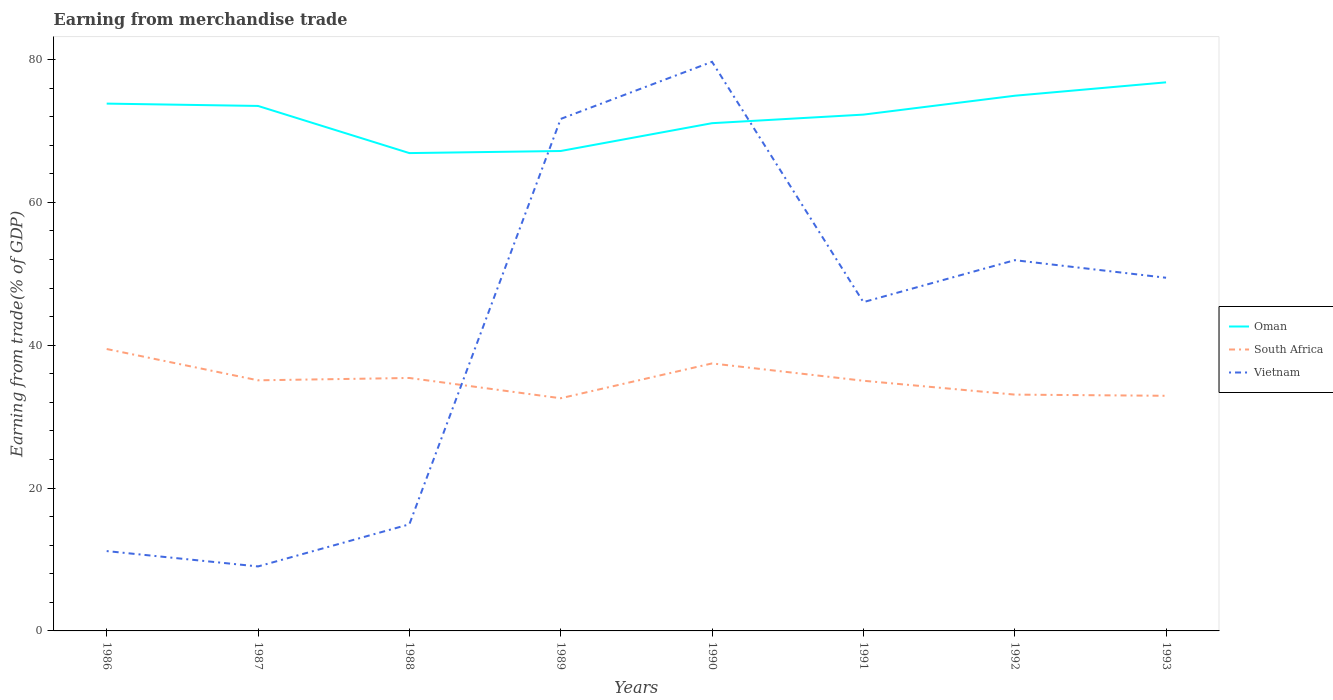How many different coloured lines are there?
Provide a succinct answer. 3. Does the line corresponding to Oman intersect with the line corresponding to South Africa?
Keep it short and to the point. No. Is the number of lines equal to the number of legend labels?
Your answer should be compact. Yes. Across all years, what is the maximum earnings from trade in South Africa?
Give a very brief answer. 32.58. What is the total earnings from trade in Vietnam in the graph?
Make the answer very short. -40.42. What is the difference between the highest and the second highest earnings from trade in Vietnam?
Provide a succinct answer. 70.65. How many lines are there?
Your answer should be compact. 3. What is the difference between two consecutive major ticks on the Y-axis?
Ensure brevity in your answer.  20. How many legend labels are there?
Offer a very short reply. 3. How are the legend labels stacked?
Your answer should be compact. Vertical. What is the title of the graph?
Offer a very short reply. Earning from merchandise trade. Does "Bhutan" appear as one of the legend labels in the graph?
Your response must be concise. No. What is the label or title of the X-axis?
Ensure brevity in your answer.  Years. What is the label or title of the Y-axis?
Your answer should be compact. Earning from trade(% of GDP). What is the Earning from trade(% of GDP) of Oman in 1986?
Give a very brief answer. 73.82. What is the Earning from trade(% of GDP) of South Africa in 1986?
Provide a short and direct response. 39.47. What is the Earning from trade(% of GDP) in Vietnam in 1986?
Your answer should be compact. 11.18. What is the Earning from trade(% of GDP) in Oman in 1987?
Your response must be concise. 73.5. What is the Earning from trade(% of GDP) in South Africa in 1987?
Offer a terse response. 35.08. What is the Earning from trade(% of GDP) of Vietnam in 1987?
Your answer should be compact. 9.03. What is the Earning from trade(% of GDP) in Oman in 1988?
Keep it short and to the point. 66.9. What is the Earning from trade(% of GDP) in South Africa in 1988?
Give a very brief answer. 35.41. What is the Earning from trade(% of GDP) of Vietnam in 1988?
Provide a succinct answer. 14.92. What is the Earning from trade(% of GDP) in Oman in 1989?
Offer a very short reply. 67.19. What is the Earning from trade(% of GDP) of South Africa in 1989?
Offer a terse response. 32.58. What is the Earning from trade(% of GDP) of Vietnam in 1989?
Your response must be concise. 71.68. What is the Earning from trade(% of GDP) of Oman in 1990?
Your answer should be compact. 71.08. What is the Earning from trade(% of GDP) in South Africa in 1990?
Keep it short and to the point. 37.45. What is the Earning from trade(% of GDP) of Vietnam in 1990?
Your answer should be compact. 79.68. What is the Earning from trade(% of GDP) of Oman in 1991?
Provide a succinct answer. 72.28. What is the Earning from trade(% of GDP) of South Africa in 1991?
Your response must be concise. 35.02. What is the Earning from trade(% of GDP) of Vietnam in 1991?
Your answer should be compact. 46.03. What is the Earning from trade(% of GDP) in Oman in 1992?
Give a very brief answer. 74.93. What is the Earning from trade(% of GDP) of South Africa in 1992?
Provide a short and direct response. 33.08. What is the Earning from trade(% of GDP) of Vietnam in 1992?
Provide a succinct answer. 51.9. What is the Earning from trade(% of GDP) in Oman in 1993?
Your answer should be compact. 76.8. What is the Earning from trade(% of GDP) of South Africa in 1993?
Ensure brevity in your answer.  32.92. What is the Earning from trade(% of GDP) of Vietnam in 1993?
Keep it short and to the point. 49.44. Across all years, what is the maximum Earning from trade(% of GDP) of Oman?
Ensure brevity in your answer.  76.8. Across all years, what is the maximum Earning from trade(% of GDP) of South Africa?
Ensure brevity in your answer.  39.47. Across all years, what is the maximum Earning from trade(% of GDP) of Vietnam?
Offer a very short reply. 79.68. Across all years, what is the minimum Earning from trade(% of GDP) of Oman?
Offer a terse response. 66.9. Across all years, what is the minimum Earning from trade(% of GDP) in South Africa?
Ensure brevity in your answer.  32.58. Across all years, what is the minimum Earning from trade(% of GDP) in Vietnam?
Offer a terse response. 9.03. What is the total Earning from trade(% of GDP) in Oman in the graph?
Make the answer very short. 576.5. What is the total Earning from trade(% of GDP) in South Africa in the graph?
Keep it short and to the point. 281.01. What is the total Earning from trade(% of GDP) in Vietnam in the graph?
Ensure brevity in your answer.  333.86. What is the difference between the Earning from trade(% of GDP) of Oman in 1986 and that in 1987?
Provide a short and direct response. 0.33. What is the difference between the Earning from trade(% of GDP) of South Africa in 1986 and that in 1987?
Keep it short and to the point. 4.38. What is the difference between the Earning from trade(% of GDP) of Vietnam in 1986 and that in 1987?
Offer a terse response. 2.15. What is the difference between the Earning from trade(% of GDP) in Oman in 1986 and that in 1988?
Make the answer very short. 6.93. What is the difference between the Earning from trade(% of GDP) of South Africa in 1986 and that in 1988?
Keep it short and to the point. 4.05. What is the difference between the Earning from trade(% of GDP) in Vietnam in 1986 and that in 1988?
Give a very brief answer. -3.74. What is the difference between the Earning from trade(% of GDP) in Oman in 1986 and that in 1989?
Offer a very short reply. 6.64. What is the difference between the Earning from trade(% of GDP) of South Africa in 1986 and that in 1989?
Provide a succinct answer. 6.89. What is the difference between the Earning from trade(% of GDP) of Vietnam in 1986 and that in 1989?
Your answer should be very brief. -60.5. What is the difference between the Earning from trade(% of GDP) of Oman in 1986 and that in 1990?
Your answer should be compact. 2.74. What is the difference between the Earning from trade(% of GDP) of South Africa in 1986 and that in 1990?
Ensure brevity in your answer.  2.02. What is the difference between the Earning from trade(% of GDP) of Vietnam in 1986 and that in 1990?
Your answer should be compact. -68.5. What is the difference between the Earning from trade(% of GDP) in Oman in 1986 and that in 1991?
Offer a terse response. 1.54. What is the difference between the Earning from trade(% of GDP) of South Africa in 1986 and that in 1991?
Your answer should be very brief. 4.44. What is the difference between the Earning from trade(% of GDP) in Vietnam in 1986 and that in 1991?
Ensure brevity in your answer.  -34.85. What is the difference between the Earning from trade(% of GDP) of Oman in 1986 and that in 1992?
Provide a succinct answer. -1.1. What is the difference between the Earning from trade(% of GDP) of South Africa in 1986 and that in 1992?
Offer a terse response. 6.38. What is the difference between the Earning from trade(% of GDP) of Vietnam in 1986 and that in 1992?
Provide a short and direct response. -40.73. What is the difference between the Earning from trade(% of GDP) in Oman in 1986 and that in 1993?
Offer a terse response. -2.98. What is the difference between the Earning from trade(% of GDP) in South Africa in 1986 and that in 1993?
Your answer should be very brief. 6.55. What is the difference between the Earning from trade(% of GDP) in Vietnam in 1986 and that in 1993?
Offer a very short reply. -38.27. What is the difference between the Earning from trade(% of GDP) in Oman in 1987 and that in 1988?
Your response must be concise. 6.6. What is the difference between the Earning from trade(% of GDP) of South Africa in 1987 and that in 1988?
Your response must be concise. -0.33. What is the difference between the Earning from trade(% of GDP) of Vietnam in 1987 and that in 1988?
Offer a terse response. -5.9. What is the difference between the Earning from trade(% of GDP) in Oman in 1987 and that in 1989?
Offer a terse response. 6.31. What is the difference between the Earning from trade(% of GDP) in South Africa in 1987 and that in 1989?
Keep it short and to the point. 2.51. What is the difference between the Earning from trade(% of GDP) of Vietnam in 1987 and that in 1989?
Offer a terse response. -62.65. What is the difference between the Earning from trade(% of GDP) in Oman in 1987 and that in 1990?
Ensure brevity in your answer.  2.41. What is the difference between the Earning from trade(% of GDP) of South Africa in 1987 and that in 1990?
Ensure brevity in your answer.  -2.36. What is the difference between the Earning from trade(% of GDP) in Vietnam in 1987 and that in 1990?
Make the answer very short. -70.65. What is the difference between the Earning from trade(% of GDP) in Oman in 1987 and that in 1991?
Your answer should be very brief. 1.21. What is the difference between the Earning from trade(% of GDP) in South Africa in 1987 and that in 1991?
Your answer should be very brief. 0.06. What is the difference between the Earning from trade(% of GDP) of Vietnam in 1987 and that in 1991?
Your answer should be compact. -37.01. What is the difference between the Earning from trade(% of GDP) of Oman in 1987 and that in 1992?
Keep it short and to the point. -1.43. What is the difference between the Earning from trade(% of GDP) of South Africa in 1987 and that in 1992?
Give a very brief answer. 2. What is the difference between the Earning from trade(% of GDP) in Vietnam in 1987 and that in 1992?
Your response must be concise. -42.88. What is the difference between the Earning from trade(% of GDP) of Oman in 1987 and that in 1993?
Provide a short and direct response. -3.31. What is the difference between the Earning from trade(% of GDP) in South Africa in 1987 and that in 1993?
Provide a short and direct response. 2.17. What is the difference between the Earning from trade(% of GDP) of Vietnam in 1987 and that in 1993?
Your answer should be compact. -40.42. What is the difference between the Earning from trade(% of GDP) in Oman in 1988 and that in 1989?
Your answer should be very brief. -0.29. What is the difference between the Earning from trade(% of GDP) in South Africa in 1988 and that in 1989?
Provide a succinct answer. 2.84. What is the difference between the Earning from trade(% of GDP) in Vietnam in 1988 and that in 1989?
Your response must be concise. -56.76. What is the difference between the Earning from trade(% of GDP) in Oman in 1988 and that in 1990?
Keep it short and to the point. -4.19. What is the difference between the Earning from trade(% of GDP) of South Africa in 1988 and that in 1990?
Your answer should be compact. -2.04. What is the difference between the Earning from trade(% of GDP) in Vietnam in 1988 and that in 1990?
Your answer should be very brief. -64.75. What is the difference between the Earning from trade(% of GDP) of Oman in 1988 and that in 1991?
Your answer should be compact. -5.39. What is the difference between the Earning from trade(% of GDP) in South Africa in 1988 and that in 1991?
Your response must be concise. 0.39. What is the difference between the Earning from trade(% of GDP) of Vietnam in 1988 and that in 1991?
Your response must be concise. -31.11. What is the difference between the Earning from trade(% of GDP) in Oman in 1988 and that in 1992?
Give a very brief answer. -8.03. What is the difference between the Earning from trade(% of GDP) in South Africa in 1988 and that in 1992?
Give a very brief answer. 2.33. What is the difference between the Earning from trade(% of GDP) in Vietnam in 1988 and that in 1992?
Offer a terse response. -36.98. What is the difference between the Earning from trade(% of GDP) in Oman in 1988 and that in 1993?
Keep it short and to the point. -9.91. What is the difference between the Earning from trade(% of GDP) in South Africa in 1988 and that in 1993?
Keep it short and to the point. 2.49. What is the difference between the Earning from trade(% of GDP) in Vietnam in 1988 and that in 1993?
Give a very brief answer. -34.52. What is the difference between the Earning from trade(% of GDP) in Oman in 1989 and that in 1990?
Offer a very short reply. -3.89. What is the difference between the Earning from trade(% of GDP) in South Africa in 1989 and that in 1990?
Offer a very short reply. -4.87. What is the difference between the Earning from trade(% of GDP) of Vietnam in 1989 and that in 1990?
Offer a very short reply. -8. What is the difference between the Earning from trade(% of GDP) in Oman in 1989 and that in 1991?
Provide a succinct answer. -5.1. What is the difference between the Earning from trade(% of GDP) in South Africa in 1989 and that in 1991?
Your answer should be compact. -2.45. What is the difference between the Earning from trade(% of GDP) in Vietnam in 1989 and that in 1991?
Your answer should be compact. 25.65. What is the difference between the Earning from trade(% of GDP) in Oman in 1989 and that in 1992?
Ensure brevity in your answer.  -7.74. What is the difference between the Earning from trade(% of GDP) of South Africa in 1989 and that in 1992?
Keep it short and to the point. -0.51. What is the difference between the Earning from trade(% of GDP) of Vietnam in 1989 and that in 1992?
Provide a short and direct response. 19.77. What is the difference between the Earning from trade(% of GDP) in Oman in 1989 and that in 1993?
Give a very brief answer. -9.61. What is the difference between the Earning from trade(% of GDP) in South Africa in 1989 and that in 1993?
Keep it short and to the point. -0.34. What is the difference between the Earning from trade(% of GDP) of Vietnam in 1989 and that in 1993?
Give a very brief answer. 22.24. What is the difference between the Earning from trade(% of GDP) in Oman in 1990 and that in 1991?
Provide a succinct answer. -1.2. What is the difference between the Earning from trade(% of GDP) in South Africa in 1990 and that in 1991?
Offer a terse response. 2.42. What is the difference between the Earning from trade(% of GDP) of Vietnam in 1990 and that in 1991?
Your answer should be compact. 33.64. What is the difference between the Earning from trade(% of GDP) in Oman in 1990 and that in 1992?
Ensure brevity in your answer.  -3.84. What is the difference between the Earning from trade(% of GDP) in South Africa in 1990 and that in 1992?
Ensure brevity in your answer.  4.37. What is the difference between the Earning from trade(% of GDP) of Vietnam in 1990 and that in 1992?
Provide a short and direct response. 27.77. What is the difference between the Earning from trade(% of GDP) of Oman in 1990 and that in 1993?
Your response must be concise. -5.72. What is the difference between the Earning from trade(% of GDP) in South Africa in 1990 and that in 1993?
Offer a terse response. 4.53. What is the difference between the Earning from trade(% of GDP) in Vietnam in 1990 and that in 1993?
Ensure brevity in your answer.  30.23. What is the difference between the Earning from trade(% of GDP) in Oman in 1991 and that in 1992?
Your answer should be compact. -2.64. What is the difference between the Earning from trade(% of GDP) of South Africa in 1991 and that in 1992?
Offer a very short reply. 1.94. What is the difference between the Earning from trade(% of GDP) of Vietnam in 1991 and that in 1992?
Give a very brief answer. -5.87. What is the difference between the Earning from trade(% of GDP) of Oman in 1991 and that in 1993?
Your answer should be compact. -4.52. What is the difference between the Earning from trade(% of GDP) of South Africa in 1991 and that in 1993?
Keep it short and to the point. 2.11. What is the difference between the Earning from trade(% of GDP) in Vietnam in 1991 and that in 1993?
Provide a short and direct response. -3.41. What is the difference between the Earning from trade(% of GDP) of Oman in 1992 and that in 1993?
Offer a terse response. -1.88. What is the difference between the Earning from trade(% of GDP) in South Africa in 1992 and that in 1993?
Keep it short and to the point. 0.16. What is the difference between the Earning from trade(% of GDP) of Vietnam in 1992 and that in 1993?
Provide a succinct answer. 2.46. What is the difference between the Earning from trade(% of GDP) in Oman in 1986 and the Earning from trade(% of GDP) in South Africa in 1987?
Provide a short and direct response. 38.74. What is the difference between the Earning from trade(% of GDP) of Oman in 1986 and the Earning from trade(% of GDP) of Vietnam in 1987?
Ensure brevity in your answer.  64.8. What is the difference between the Earning from trade(% of GDP) of South Africa in 1986 and the Earning from trade(% of GDP) of Vietnam in 1987?
Keep it short and to the point. 30.44. What is the difference between the Earning from trade(% of GDP) of Oman in 1986 and the Earning from trade(% of GDP) of South Africa in 1988?
Keep it short and to the point. 38.41. What is the difference between the Earning from trade(% of GDP) in Oman in 1986 and the Earning from trade(% of GDP) in Vietnam in 1988?
Give a very brief answer. 58.9. What is the difference between the Earning from trade(% of GDP) of South Africa in 1986 and the Earning from trade(% of GDP) of Vietnam in 1988?
Ensure brevity in your answer.  24.54. What is the difference between the Earning from trade(% of GDP) of Oman in 1986 and the Earning from trade(% of GDP) of South Africa in 1989?
Offer a terse response. 41.25. What is the difference between the Earning from trade(% of GDP) in Oman in 1986 and the Earning from trade(% of GDP) in Vietnam in 1989?
Offer a terse response. 2.14. What is the difference between the Earning from trade(% of GDP) of South Africa in 1986 and the Earning from trade(% of GDP) of Vietnam in 1989?
Your answer should be compact. -32.21. What is the difference between the Earning from trade(% of GDP) in Oman in 1986 and the Earning from trade(% of GDP) in South Africa in 1990?
Make the answer very short. 36.38. What is the difference between the Earning from trade(% of GDP) of Oman in 1986 and the Earning from trade(% of GDP) of Vietnam in 1990?
Your response must be concise. -5.85. What is the difference between the Earning from trade(% of GDP) in South Africa in 1986 and the Earning from trade(% of GDP) in Vietnam in 1990?
Ensure brevity in your answer.  -40.21. What is the difference between the Earning from trade(% of GDP) in Oman in 1986 and the Earning from trade(% of GDP) in South Africa in 1991?
Your answer should be compact. 38.8. What is the difference between the Earning from trade(% of GDP) in Oman in 1986 and the Earning from trade(% of GDP) in Vietnam in 1991?
Make the answer very short. 27.79. What is the difference between the Earning from trade(% of GDP) in South Africa in 1986 and the Earning from trade(% of GDP) in Vietnam in 1991?
Your answer should be very brief. -6.56. What is the difference between the Earning from trade(% of GDP) in Oman in 1986 and the Earning from trade(% of GDP) in South Africa in 1992?
Provide a succinct answer. 40.74. What is the difference between the Earning from trade(% of GDP) of Oman in 1986 and the Earning from trade(% of GDP) of Vietnam in 1992?
Your answer should be compact. 21.92. What is the difference between the Earning from trade(% of GDP) in South Africa in 1986 and the Earning from trade(% of GDP) in Vietnam in 1992?
Ensure brevity in your answer.  -12.44. What is the difference between the Earning from trade(% of GDP) of Oman in 1986 and the Earning from trade(% of GDP) of South Africa in 1993?
Your answer should be compact. 40.91. What is the difference between the Earning from trade(% of GDP) in Oman in 1986 and the Earning from trade(% of GDP) in Vietnam in 1993?
Your answer should be very brief. 24.38. What is the difference between the Earning from trade(% of GDP) in South Africa in 1986 and the Earning from trade(% of GDP) in Vietnam in 1993?
Give a very brief answer. -9.98. What is the difference between the Earning from trade(% of GDP) of Oman in 1987 and the Earning from trade(% of GDP) of South Africa in 1988?
Offer a very short reply. 38.08. What is the difference between the Earning from trade(% of GDP) in Oman in 1987 and the Earning from trade(% of GDP) in Vietnam in 1988?
Give a very brief answer. 58.57. What is the difference between the Earning from trade(% of GDP) in South Africa in 1987 and the Earning from trade(% of GDP) in Vietnam in 1988?
Ensure brevity in your answer.  20.16. What is the difference between the Earning from trade(% of GDP) in Oman in 1987 and the Earning from trade(% of GDP) in South Africa in 1989?
Provide a short and direct response. 40.92. What is the difference between the Earning from trade(% of GDP) of Oman in 1987 and the Earning from trade(% of GDP) of Vietnam in 1989?
Offer a very short reply. 1.82. What is the difference between the Earning from trade(% of GDP) of South Africa in 1987 and the Earning from trade(% of GDP) of Vietnam in 1989?
Give a very brief answer. -36.59. What is the difference between the Earning from trade(% of GDP) in Oman in 1987 and the Earning from trade(% of GDP) in South Africa in 1990?
Keep it short and to the point. 36.05. What is the difference between the Earning from trade(% of GDP) of Oman in 1987 and the Earning from trade(% of GDP) of Vietnam in 1990?
Offer a very short reply. -6.18. What is the difference between the Earning from trade(% of GDP) of South Africa in 1987 and the Earning from trade(% of GDP) of Vietnam in 1990?
Give a very brief answer. -44.59. What is the difference between the Earning from trade(% of GDP) in Oman in 1987 and the Earning from trade(% of GDP) in South Africa in 1991?
Your response must be concise. 38.47. What is the difference between the Earning from trade(% of GDP) of Oman in 1987 and the Earning from trade(% of GDP) of Vietnam in 1991?
Give a very brief answer. 27.47. What is the difference between the Earning from trade(% of GDP) in South Africa in 1987 and the Earning from trade(% of GDP) in Vietnam in 1991?
Give a very brief answer. -10.95. What is the difference between the Earning from trade(% of GDP) in Oman in 1987 and the Earning from trade(% of GDP) in South Africa in 1992?
Give a very brief answer. 40.41. What is the difference between the Earning from trade(% of GDP) in Oman in 1987 and the Earning from trade(% of GDP) in Vietnam in 1992?
Your response must be concise. 21.59. What is the difference between the Earning from trade(% of GDP) of South Africa in 1987 and the Earning from trade(% of GDP) of Vietnam in 1992?
Provide a short and direct response. -16.82. What is the difference between the Earning from trade(% of GDP) of Oman in 1987 and the Earning from trade(% of GDP) of South Africa in 1993?
Your response must be concise. 40.58. What is the difference between the Earning from trade(% of GDP) in Oman in 1987 and the Earning from trade(% of GDP) in Vietnam in 1993?
Make the answer very short. 24.05. What is the difference between the Earning from trade(% of GDP) in South Africa in 1987 and the Earning from trade(% of GDP) in Vietnam in 1993?
Make the answer very short. -14.36. What is the difference between the Earning from trade(% of GDP) in Oman in 1988 and the Earning from trade(% of GDP) in South Africa in 1989?
Provide a short and direct response. 34.32. What is the difference between the Earning from trade(% of GDP) of Oman in 1988 and the Earning from trade(% of GDP) of Vietnam in 1989?
Provide a succinct answer. -4.78. What is the difference between the Earning from trade(% of GDP) of South Africa in 1988 and the Earning from trade(% of GDP) of Vietnam in 1989?
Provide a succinct answer. -36.27. What is the difference between the Earning from trade(% of GDP) of Oman in 1988 and the Earning from trade(% of GDP) of South Africa in 1990?
Offer a terse response. 29.45. What is the difference between the Earning from trade(% of GDP) in Oman in 1988 and the Earning from trade(% of GDP) in Vietnam in 1990?
Your answer should be very brief. -12.78. What is the difference between the Earning from trade(% of GDP) of South Africa in 1988 and the Earning from trade(% of GDP) of Vietnam in 1990?
Your answer should be very brief. -44.26. What is the difference between the Earning from trade(% of GDP) in Oman in 1988 and the Earning from trade(% of GDP) in South Africa in 1991?
Your response must be concise. 31.87. What is the difference between the Earning from trade(% of GDP) in Oman in 1988 and the Earning from trade(% of GDP) in Vietnam in 1991?
Make the answer very short. 20.86. What is the difference between the Earning from trade(% of GDP) of South Africa in 1988 and the Earning from trade(% of GDP) of Vietnam in 1991?
Your answer should be very brief. -10.62. What is the difference between the Earning from trade(% of GDP) in Oman in 1988 and the Earning from trade(% of GDP) in South Africa in 1992?
Keep it short and to the point. 33.81. What is the difference between the Earning from trade(% of GDP) in Oman in 1988 and the Earning from trade(% of GDP) in Vietnam in 1992?
Your answer should be compact. 14.99. What is the difference between the Earning from trade(% of GDP) in South Africa in 1988 and the Earning from trade(% of GDP) in Vietnam in 1992?
Offer a very short reply. -16.49. What is the difference between the Earning from trade(% of GDP) in Oman in 1988 and the Earning from trade(% of GDP) in South Africa in 1993?
Your answer should be compact. 33.98. What is the difference between the Earning from trade(% of GDP) in Oman in 1988 and the Earning from trade(% of GDP) in Vietnam in 1993?
Provide a short and direct response. 17.45. What is the difference between the Earning from trade(% of GDP) in South Africa in 1988 and the Earning from trade(% of GDP) in Vietnam in 1993?
Offer a terse response. -14.03. What is the difference between the Earning from trade(% of GDP) of Oman in 1989 and the Earning from trade(% of GDP) of South Africa in 1990?
Your answer should be compact. 29.74. What is the difference between the Earning from trade(% of GDP) of Oman in 1989 and the Earning from trade(% of GDP) of Vietnam in 1990?
Make the answer very short. -12.49. What is the difference between the Earning from trade(% of GDP) of South Africa in 1989 and the Earning from trade(% of GDP) of Vietnam in 1990?
Provide a short and direct response. -47.1. What is the difference between the Earning from trade(% of GDP) of Oman in 1989 and the Earning from trade(% of GDP) of South Africa in 1991?
Provide a short and direct response. 32.16. What is the difference between the Earning from trade(% of GDP) in Oman in 1989 and the Earning from trade(% of GDP) in Vietnam in 1991?
Provide a succinct answer. 21.16. What is the difference between the Earning from trade(% of GDP) in South Africa in 1989 and the Earning from trade(% of GDP) in Vietnam in 1991?
Your response must be concise. -13.46. What is the difference between the Earning from trade(% of GDP) in Oman in 1989 and the Earning from trade(% of GDP) in South Africa in 1992?
Provide a succinct answer. 34.11. What is the difference between the Earning from trade(% of GDP) in Oman in 1989 and the Earning from trade(% of GDP) in Vietnam in 1992?
Offer a terse response. 15.28. What is the difference between the Earning from trade(% of GDP) of South Africa in 1989 and the Earning from trade(% of GDP) of Vietnam in 1992?
Your answer should be very brief. -19.33. What is the difference between the Earning from trade(% of GDP) in Oman in 1989 and the Earning from trade(% of GDP) in South Africa in 1993?
Offer a terse response. 34.27. What is the difference between the Earning from trade(% of GDP) of Oman in 1989 and the Earning from trade(% of GDP) of Vietnam in 1993?
Your response must be concise. 17.74. What is the difference between the Earning from trade(% of GDP) of South Africa in 1989 and the Earning from trade(% of GDP) of Vietnam in 1993?
Ensure brevity in your answer.  -16.87. What is the difference between the Earning from trade(% of GDP) in Oman in 1990 and the Earning from trade(% of GDP) in South Africa in 1991?
Give a very brief answer. 36.06. What is the difference between the Earning from trade(% of GDP) of Oman in 1990 and the Earning from trade(% of GDP) of Vietnam in 1991?
Offer a very short reply. 25.05. What is the difference between the Earning from trade(% of GDP) in South Africa in 1990 and the Earning from trade(% of GDP) in Vietnam in 1991?
Offer a terse response. -8.58. What is the difference between the Earning from trade(% of GDP) in Oman in 1990 and the Earning from trade(% of GDP) in South Africa in 1992?
Give a very brief answer. 38. What is the difference between the Earning from trade(% of GDP) in Oman in 1990 and the Earning from trade(% of GDP) in Vietnam in 1992?
Your answer should be compact. 19.18. What is the difference between the Earning from trade(% of GDP) of South Africa in 1990 and the Earning from trade(% of GDP) of Vietnam in 1992?
Keep it short and to the point. -14.46. What is the difference between the Earning from trade(% of GDP) in Oman in 1990 and the Earning from trade(% of GDP) in South Africa in 1993?
Provide a succinct answer. 38.16. What is the difference between the Earning from trade(% of GDP) in Oman in 1990 and the Earning from trade(% of GDP) in Vietnam in 1993?
Provide a short and direct response. 21.64. What is the difference between the Earning from trade(% of GDP) of South Africa in 1990 and the Earning from trade(% of GDP) of Vietnam in 1993?
Offer a very short reply. -12. What is the difference between the Earning from trade(% of GDP) in Oman in 1991 and the Earning from trade(% of GDP) in South Africa in 1992?
Provide a short and direct response. 39.2. What is the difference between the Earning from trade(% of GDP) in Oman in 1991 and the Earning from trade(% of GDP) in Vietnam in 1992?
Your answer should be very brief. 20.38. What is the difference between the Earning from trade(% of GDP) in South Africa in 1991 and the Earning from trade(% of GDP) in Vietnam in 1992?
Provide a succinct answer. -16.88. What is the difference between the Earning from trade(% of GDP) of Oman in 1991 and the Earning from trade(% of GDP) of South Africa in 1993?
Your answer should be very brief. 39.36. What is the difference between the Earning from trade(% of GDP) in Oman in 1991 and the Earning from trade(% of GDP) in Vietnam in 1993?
Provide a short and direct response. 22.84. What is the difference between the Earning from trade(% of GDP) in South Africa in 1991 and the Earning from trade(% of GDP) in Vietnam in 1993?
Ensure brevity in your answer.  -14.42. What is the difference between the Earning from trade(% of GDP) in Oman in 1992 and the Earning from trade(% of GDP) in South Africa in 1993?
Offer a terse response. 42.01. What is the difference between the Earning from trade(% of GDP) in Oman in 1992 and the Earning from trade(% of GDP) in Vietnam in 1993?
Offer a very short reply. 25.48. What is the difference between the Earning from trade(% of GDP) in South Africa in 1992 and the Earning from trade(% of GDP) in Vietnam in 1993?
Make the answer very short. -16.36. What is the average Earning from trade(% of GDP) of Oman per year?
Give a very brief answer. 72.06. What is the average Earning from trade(% of GDP) in South Africa per year?
Offer a terse response. 35.13. What is the average Earning from trade(% of GDP) in Vietnam per year?
Give a very brief answer. 41.73. In the year 1986, what is the difference between the Earning from trade(% of GDP) in Oman and Earning from trade(% of GDP) in South Africa?
Make the answer very short. 34.36. In the year 1986, what is the difference between the Earning from trade(% of GDP) of Oman and Earning from trade(% of GDP) of Vietnam?
Provide a short and direct response. 62.65. In the year 1986, what is the difference between the Earning from trade(% of GDP) in South Africa and Earning from trade(% of GDP) in Vietnam?
Your answer should be very brief. 28.29. In the year 1987, what is the difference between the Earning from trade(% of GDP) in Oman and Earning from trade(% of GDP) in South Africa?
Make the answer very short. 38.41. In the year 1987, what is the difference between the Earning from trade(% of GDP) of Oman and Earning from trade(% of GDP) of Vietnam?
Keep it short and to the point. 64.47. In the year 1987, what is the difference between the Earning from trade(% of GDP) of South Africa and Earning from trade(% of GDP) of Vietnam?
Offer a terse response. 26.06. In the year 1988, what is the difference between the Earning from trade(% of GDP) in Oman and Earning from trade(% of GDP) in South Africa?
Provide a succinct answer. 31.48. In the year 1988, what is the difference between the Earning from trade(% of GDP) in Oman and Earning from trade(% of GDP) in Vietnam?
Provide a short and direct response. 51.97. In the year 1988, what is the difference between the Earning from trade(% of GDP) in South Africa and Earning from trade(% of GDP) in Vietnam?
Your response must be concise. 20.49. In the year 1989, what is the difference between the Earning from trade(% of GDP) in Oman and Earning from trade(% of GDP) in South Africa?
Your answer should be compact. 34.61. In the year 1989, what is the difference between the Earning from trade(% of GDP) of Oman and Earning from trade(% of GDP) of Vietnam?
Your answer should be compact. -4.49. In the year 1989, what is the difference between the Earning from trade(% of GDP) of South Africa and Earning from trade(% of GDP) of Vietnam?
Provide a short and direct response. -39.1. In the year 1990, what is the difference between the Earning from trade(% of GDP) in Oman and Earning from trade(% of GDP) in South Africa?
Ensure brevity in your answer.  33.63. In the year 1990, what is the difference between the Earning from trade(% of GDP) of Oman and Earning from trade(% of GDP) of Vietnam?
Your response must be concise. -8.59. In the year 1990, what is the difference between the Earning from trade(% of GDP) of South Africa and Earning from trade(% of GDP) of Vietnam?
Your response must be concise. -42.23. In the year 1991, what is the difference between the Earning from trade(% of GDP) of Oman and Earning from trade(% of GDP) of South Africa?
Your response must be concise. 37.26. In the year 1991, what is the difference between the Earning from trade(% of GDP) of Oman and Earning from trade(% of GDP) of Vietnam?
Your answer should be very brief. 26.25. In the year 1991, what is the difference between the Earning from trade(% of GDP) in South Africa and Earning from trade(% of GDP) in Vietnam?
Offer a very short reply. -11.01. In the year 1992, what is the difference between the Earning from trade(% of GDP) in Oman and Earning from trade(% of GDP) in South Africa?
Offer a very short reply. 41.84. In the year 1992, what is the difference between the Earning from trade(% of GDP) of Oman and Earning from trade(% of GDP) of Vietnam?
Offer a very short reply. 23.02. In the year 1992, what is the difference between the Earning from trade(% of GDP) of South Africa and Earning from trade(% of GDP) of Vietnam?
Your response must be concise. -18.82. In the year 1993, what is the difference between the Earning from trade(% of GDP) of Oman and Earning from trade(% of GDP) of South Africa?
Offer a terse response. 43.88. In the year 1993, what is the difference between the Earning from trade(% of GDP) in Oman and Earning from trade(% of GDP) in Vietnam?
Ensure brevity in your answer.  27.36. In the year 1993, what is the difference between the Earning from trade(% of GDP) in South Africa and Earning from trade(% of GDP) in Vietnam?
Offer a terse response. -16.53. What is the ratio of the Earning from trade(% of GDP) of South Africa in 1986 to that in 1987?
Make the answer very short. 1.12. What is the ratio of the Earning from trade(% of GDP) of Vietnam in 1986 to that in 1987?
Offer a terse response. 1.24. What is the ratio of the Earning from trade(% of GDP) of Oman in 1986 to that in 1988?
Your answer should be compact. 1.1. What is the ratio of the Earning from trade(% of GDP) of South Africa in 1986 to that in 1988?
Give a very brief answer. 1.11. What is the ratio of the Earning from trade(% of GDP) of Vietnam in 1986 to that in 1988?
Make the answer very short. 0.75. What is the ratio of the Earning from trade(% of GDP) in Oman in 1986 to that in 1989?
Make the answer very short. 1.1. What is the ratio of the Earning from trade(% of GDP) in South Africa in 1986 to that in 1989?
Make the answer very short. 1.21. What is the ratio of the Earning from trade(% of GDP) of Vietnam in 1986 to that in 1989?
Offer a terse response. 0.16. What is the ratio of the Earning from trade(% of GDP) in Oman in 1986 to that in 1990?
Offer a terse response. 1.04. What is the ratio of the Earning from trade(% of GDP) of South Africa in 1986 to that in 1990?
Offer a terse response. 1.05. What is the ratio of the Earning from trade(% of GDP) of Vietnam in 1986 to that in 1990?
Your response must be concise. 0.14. What is the ratio of the Earning from trade(% of GDP) of Oman in 1986 to that in 1991?
Your answer should be compact. 1.02. What is the ratio of the Earning from trade(% of GDP) of South Africa in 1986 to that in 1991?
Provide a short and direct response. 1.13. What is the ratio of the Earning from trade(% of GDP) of Vietnam in 1986 to that in 1991?
Make the answer very short. 0.24. What is the ratio of the Earning from trade(% of GDP) in Oman in 1986 to that in 1992?
Make the answer very short. 0.99. What is the ratio of the Earning from trade(% of GDP) in South Africa in 1986 to that in 1992?
Offer a very short reply. 1.19. What is the ratio of the Earning from trade(% of GDP) in Vietnam in 1986 to that in 1992?
Offer a terse response. 0.22. What is the ratio of the Earning from trade(% of GDP) in Oman in 1986 to that in 1993?
Provide a short and direct response. 0.96. What is the ratio of the Earning from trade(% of GDP) in South Africa in 1986 to that in 1993?
Keep it short and to the point. 1.2. What is the ratio of the Earning from trade(% of GDP) in Vietnam in 1986 to that in 1993?
Your answer should be very brief. 0.23. What is the ratio of the Earning from trade(% of GDP) in Oman in 1987 to that in 1988?
Your answer should be very brief. 1.1. What is the ratio of the Earning from trade(% of GDP) in Vietnam in 1987 to that in 1988?
Your answer should be very brief. 0.6. What is the ratio of the Earning from trade(% of GDP) in Oman in 1987 to that in 1989?
Offer a terse response. 1.09. What is the ratio of the Earning from trade(% of GDP) of South Africa in 1987 to that in 1989?
Keep it short and to the point. 1.08. What is the ratio of the Earning from trade(% of GDP) in Vietnam in 1987 to that in 1989?
Offer a very short reply. 0.13. What is the ratio of the Earning from trade(% of GDP) in Oman in 1987 to that in 1990?
Your answer should be compact. 1.03. What is the ratio of the Earning from trade(% of GDP) of South Africa in 1987 to that in 1990?
Provide a succinct answer. 0.94. What is the ratio of the Earning from trade(% of GDP) of Vietnam in 1987 to that in 1990?
Provide a succinct answer. 0.11. What is the ratio of the Earning from trade(% of GDP) in Oman in 1987 to that in 1991?
Your response must be concise. 1.02. What is the ratio of the Earning from trade(% of GDP) in South Africa in 1987 to that in 1991?
Give a very brief answer. 1. What is the ratio of the Earning from trade(% of GDP) of Vietnam in 1987 to that in 1991?
Your answer should be very brief. 0.2. What is the ratio of the Earning from trade(% of GDP) of Oman in 1987 to that in 1992?
Make the answer very short. 0.98. What is the ratio of the Earning from trade(% of GDP) of South Africa in 1987 to that in 1992?
Provide a short and direct response. 1.06. What is the ratio of the Earning from trade(% of GDP) of Vietnam in 1987 to that in 1992?
Make the answer very short. 0.17. What is the ratio of the Earning from trade(% of GDP) in South Africa in 1987 to that in 1993?
Make the answer very short. 1.07. What is the ratio of the Earning from trade(% of GDP) of Vietnam in 1987 to that in 1993?
Ensure brevity in your answer.  0.18. What is the ratio of the Earning from trade(% of GDP) in Oman in 1988 to that in 1989?
Offer a terse response. 1. What is the ratio of the Earning from trade(% of GDP) in South Africa in 1988 to that in 1989?
Provide a short and direct response. 1.09. What is the ratio of the Earning from trade(% of GDP) in Vietnam in 1988 to that in 1989?
Give a very brief answer. 0.21. What is the ratio of the Earning from trade(% of GDP) of Oman in 1988 to that in 1990?
Your answer should be compact. 0.94. What is the ratio of the Earning from trade(% of GDP) in South Africa in 1988 to that in 1990?
Your answer should be compact. 0.95. What is the ratio of the Earning from trade(% of GDP) in Vietnam in 1988 to that in 1990?
Make the answer very short. 0.19. What is the ratio of the Earning from trade(% of GDP) of Oman in 1988 to that in 1991?
Keep it short and to the point. 0.93. What is the ratio of the Earning from trade(% of GDP) of South Africa in 1988 to that in 1991?
Give a very brief answer. 1.01. What is the ratio of the Earning from trade(% of GDP) of Vietnam in 1988 to that in 1991?
Ensure brevity in your answer.  0.32. What is the ratio of the Earning from trade(% of GDP) in Oman in 1988 to that in 1992?
Provide a succinct answer. 0.89. What is the ratio of the Earning from trade(% of GDP) of South Africa in 1988 to that in 1992?
Ensure brevity in your answer.  1.07. What is the ratio of the Earning from trade(% of GDP) in Vietnam in 1988 to that in 1992?
Give a very brief answer. 0.29. What is the ratio of the Earning from trade(% of GDP) in Oman in 1988 to that in 1993?
Provide a short and direct response. 0.87. What is the ratio of the Earning from trade(% of GDP) of South Africa in 1988 to that in 1993?
Your response must be concise. 1.08. What is the ratio of the Earning from trade(% of GDP) of Vietnam in 1988 to that in 1993?
Provide a short and direct response. 0.3. What is the ratio of the Earning from trade(% of GDP) of Oman in 1989 to that in 1990?
Ensure brevity in your answer.  0.95. What is the ratio of the Earning from trade(% of GDP) of South Africa in 1989 to that in 1990?
Offer a very short reply. 0.87. What is the ratio of the Earning from trade(% of GDP) of Vietnam in 1989 to that in 1990?
Provide a succinct answer. 0.9. What is the ratio of the Earning from trade(% of GDP) in Oman in 1989 to that in 1991?
Your answer should be very brief. 0.93. What is the ratio of the Earning from trade(% of GDP) of South Africa in 1989 to that in 1991?
Your answer should be compact. 0.93. What is the ratio of the Earning from trade(% of GDP) of Vietnam in 1989 to that in 1991?
Offer a terse response. 1.56. What is the ratio of the Earning from trade(% of GDP) in Oman in 1989 to that in 1992?
Your answer should be very brief. 0.9. What is the ratio of the Earning from trade(% of GDP) of South Africa in 1989 to that in 1992?
Your answer should be compact. 0.98. What is the ratio of the Earning from trade(% of GDP) of Vietnam in 1989 to that in 1992?
Your response must be concise. 1.38. What is the ratio of the Earning from trade(% of GDP) of Oman in 1989 to that in 1993?
Your answer should be very brief. 0.87. What is the ratio of the Earning from trade(% of GDP) in Vietnam in 1989 to that in 1993?
Your response must be concise. 1.45. What is the ratio of the Earning from trade(% of GDP) of Oman in 1990 to that in 1991?
Your response must be concise. 0.98. What is the ratio of the Earning from trade(% of GDP) of South Africa in 1990 to that in 1991?
Offer a terse response. 1.07. What is the ratio of the Earning from trade(% of GDP) in Vietnam in 1990 to that in 1991?
Make the answer very short. 1.73. What is the ratio of the Earning from trade(% of GDP) of Oman in 1990 to that in 1992?
Your response must be concise. 0.95. What is the ratio of the Earning from trade(% of GDP) in South Africa in 1990 to that in 1992?
Offer a terse response. 1.13. What is the ratio of the Earning from trade(% of GDP) of Vietnam in 1990 to that in 1992?
Your answer should be compact. 1.54. What is the ratio of the Earning from trade(% of GDP) in Oman in 1990 to that in 1993?
Provide a succinct answer. 0.93. What is the ratio of the Earning from trade(% of GDP) of South Africa in 1990 to that in 1993?
Offer a terse response. 1.14. What is the ratio of the Earning from trade(% of GDP) in Vietnam in 1990 to that in 1993?
Keep it short and to the point. 1.61. What is the ratio of the Earning from trade(% of GDP) in Oman in 1991 to that in 1992?
Your answer should be compact. 0.96. What is the ratio of the Earning from trade(% of GDP) in South Africa in 1991 to that in 1992?
Provide a succinct answer. 1.06. What is the ratio of the Earning from trade(% of GDP) in Vietnam in 1991 to that in 1992?
Provide a succinct answer. 0.89. What is the ratio of the Earning from trade(% of GDP) in Oman in 1991 to that in 1993?
Provide a short and direct response. 0.94. What is the ratio of the Earning from trade(% of GDP) in South Africa in 1991 to that in 1993?
Your answer should be very brief. 1.06. What is the ratio of the Earning from trade(% of GDP) in Vietnam in 1991 to that in 1993?
Offer a very short reply. 0.93. What is the ratio of the Earning from trade(% of GDP) in Oman in 1992 to that in 1993?
Your answer should be very brief. 0.98. What is the ratio of the Earning from trade(% of GDP) of Vietnam in 1992 to that in 1993?
Ensure brevity in your answer.  1.05. What is the difference between the highest and the second highest Earning from trade(% of GDP) of Oman?
Keep it short and to the point. 1.88. What is the difference between the highest and the second highest Earning from trade(% of GDP) in South Africa?
Offer a very short reply. 2.02. What is the difference between the highest and the second highest Earning from trade(% of GDP) of Vietnam?
Ensure brevity in your answer.  8. What is the difference between the highest and the lowest Earning from trade(% of GDP) of Oman?
Offer a very short reply. 9.91. What is the difference between the highest and the lowest Earning from trade(% of GDP) in South Africa?
Provide a short and direct response. 6.89. What is the difference between the highest and the lowest Earning from trade(% of GDP) in Vietnam?
Offer a terse response. 70.65. 